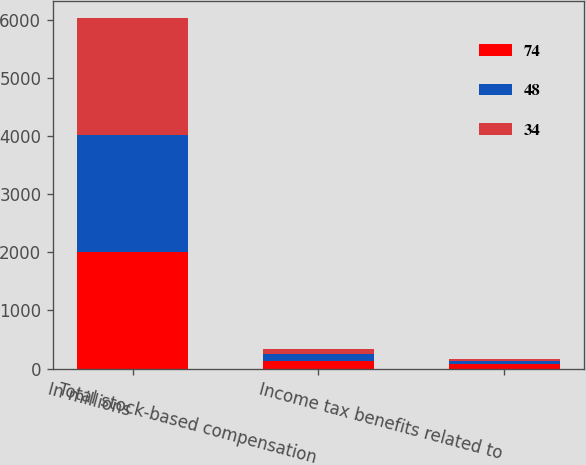<chart> <loc_0><loc_0><loc_500><loc_500><stacked_bar_chart><ecel><fcel>In millions<fcel>Total stock-based compensation<fcel>Income tax benefits related to<nl><fcel>74<fcel>2013<fcel>137<fcel>74<nl><fcel>48<fcel>2012<fcel>116<fcel>48<nl><fcel>34<fcel>2011<fcel>84<fcel>34<nl></chart> 